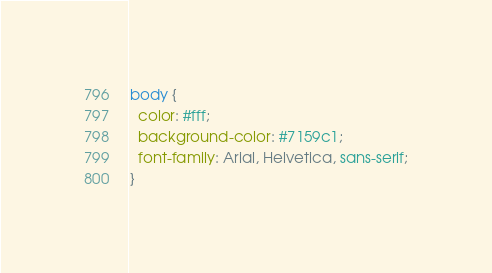<code> <loc_0><loc_0><loc_500><loc_500><_CSS_>body {
  color: #fff;
  background-color: #7159c1;
  font-family: Arial, Helvetica, sans-serif;
}
</code> 